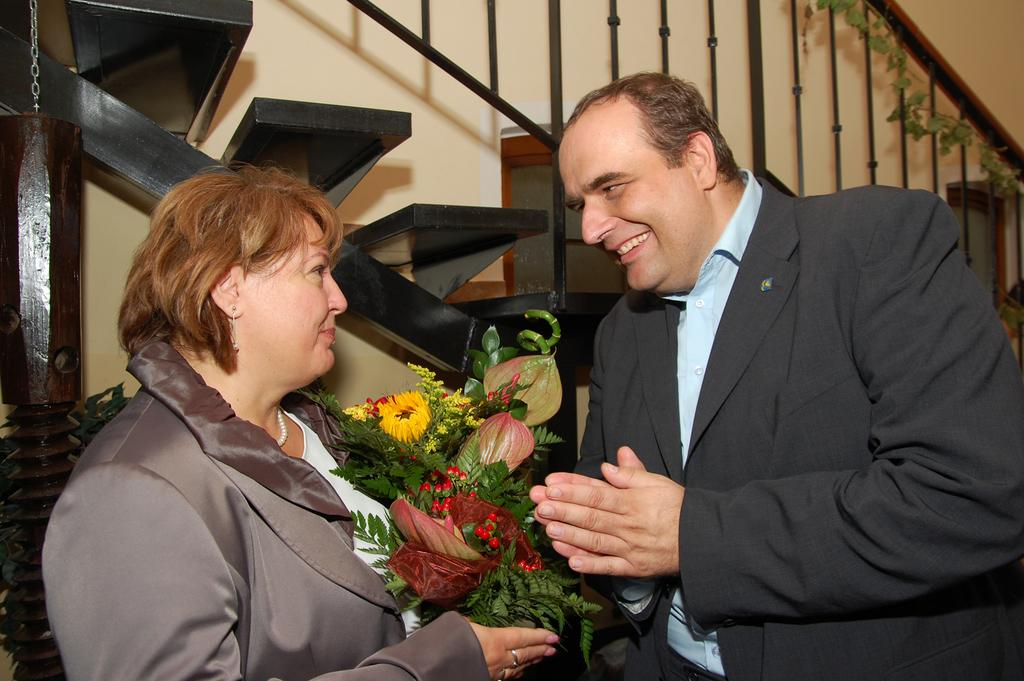How many people are in the image? There are two persons in the image. What are the expressions on their faces? Both persons are smiling. What is one of the persons holding? One of the persons is holding a bouquet. What can be seen in the background of the image? There is a wall and steps in the background of the image. What type of button is being used to fold the turkey in the image? There is no button or turkey present in the image. 